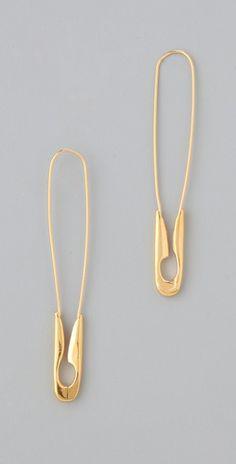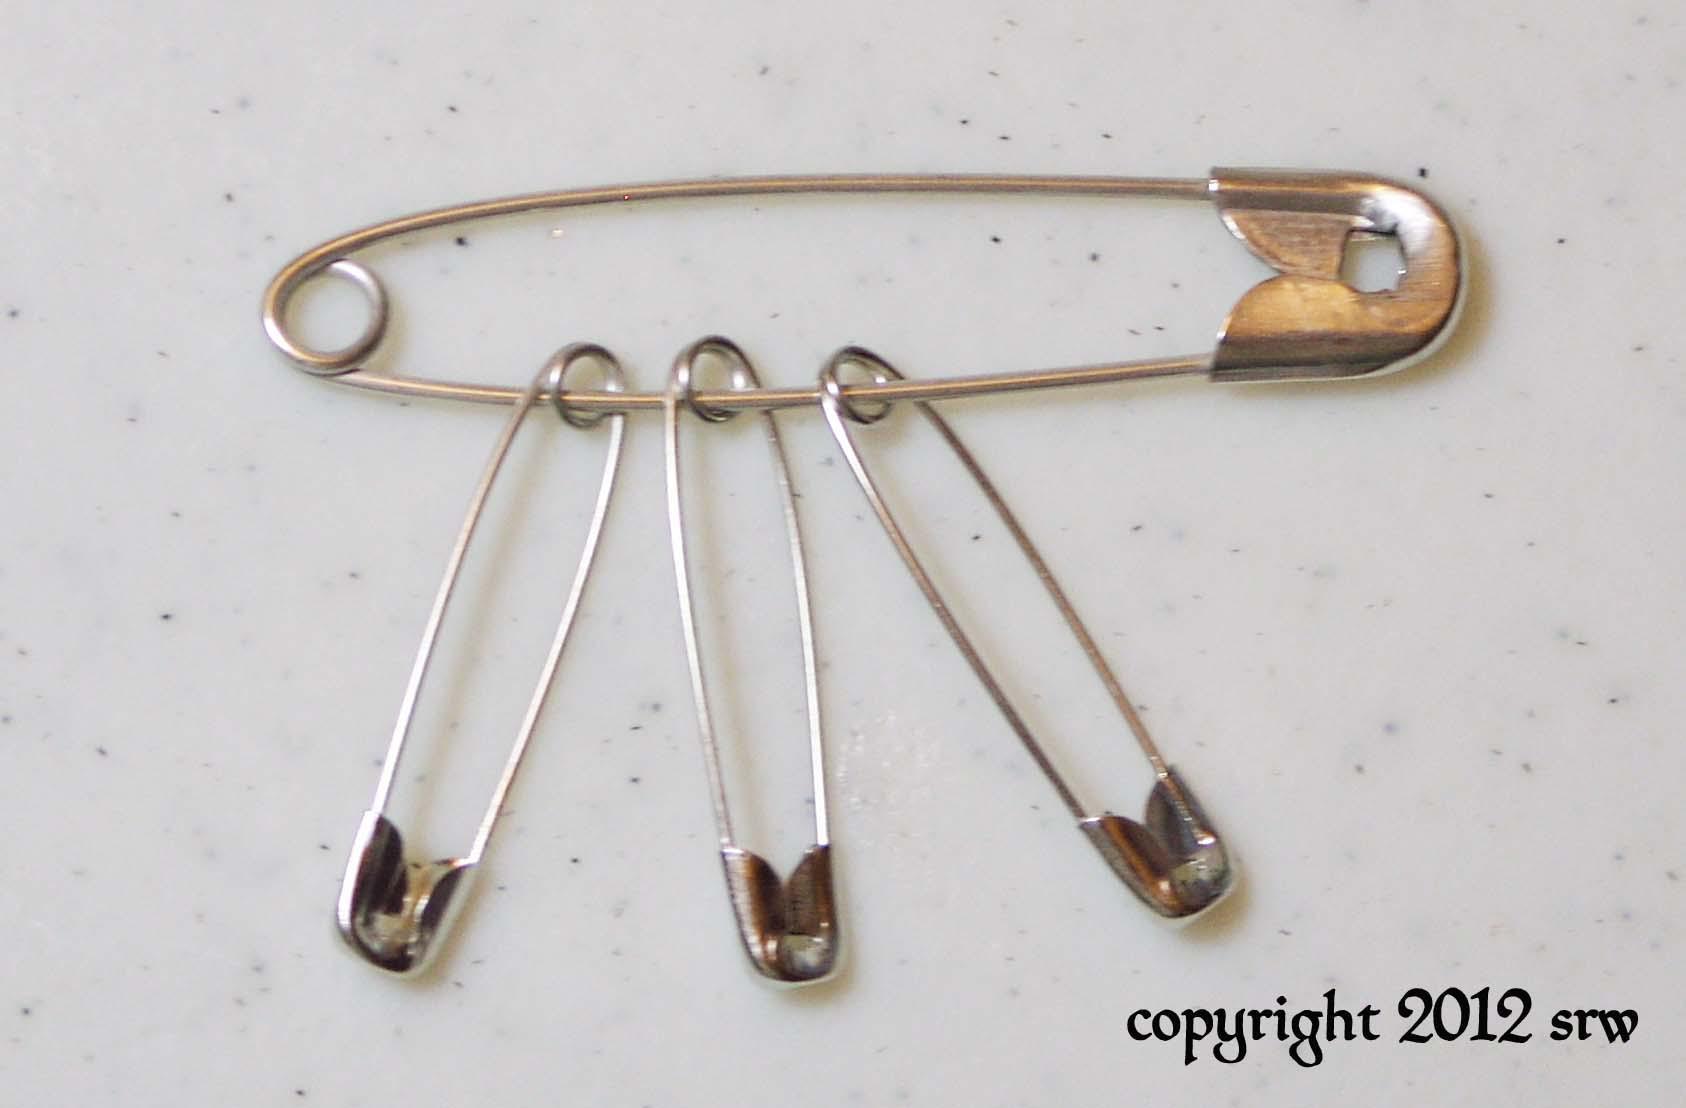The first image is the image on the left, the second image is the image on the right. For the images displayed, is the sentence "The left image contains exactly two unadorned, separate safety pins, and the right image contains exactly four safety pins." factually correct? Answer yes or no. Yes. The first image is the image on the left, the second image is the image on the right. Examine the images to the left and right. Is the description "Safety pins have be beaded to become fashion accessories. ." accurate? Answer yes or no. No. 